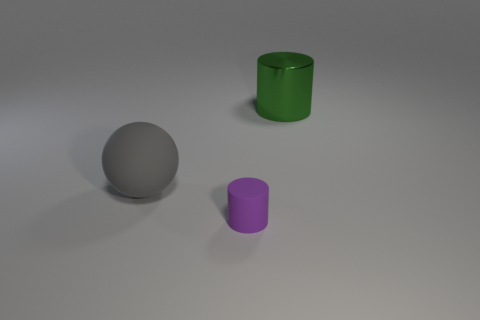Can you tell me more about the colors and textures of the objects in the image? The image showcases three objects with distinct colors and textures. The sphere on the left has a muted gray color with a matte finish, absorbing most of the light. The cylinder in the middle sports a vibrant green hue with a shiny, reflective surface, indicating a glossy texture. Lastly, there's a smaller cylinder with a purple color, which also seems to have a matte finish similar to the gray sphere. 